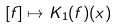<formula> <loc_0><loc_0><loc_500><loc_500>[ f ] \mapsto K _ { 1 } ( f ) ( x )</formula> 